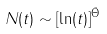Convert formula to latex. <formula><loc_0><loc_0><loc_500><loc_500>N ( t ) \sim [ \ln ( t ) ] ^ { \bar { \Theta } }</formula> 